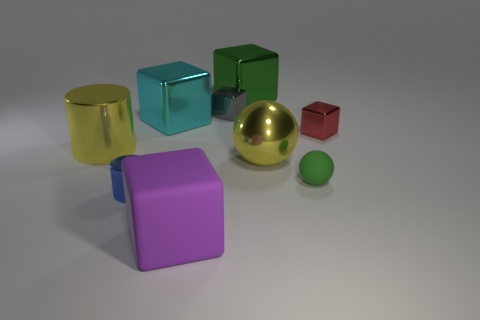Subtract all gray cubes. How many cubes are left? 4 Subtract all cyan blocks. How many blocks are left? 4 Subtract all yellow blocks. Subtract all green cylinders. How many blocks are left? 5 Add 1 small green matte cubes. How many objects exist? 10 Subtract all blocks. How many objects are left? 4 Add 4 tiny yellow objects. How many tiny yellow objects exist? 4 Subtract 1 gray blocks. How many objects are left? 8 Subtract all tiny green spheres. Subtract all large things. How many objects are left? 3 Add 3 big green things. How many big green things are left? 4 